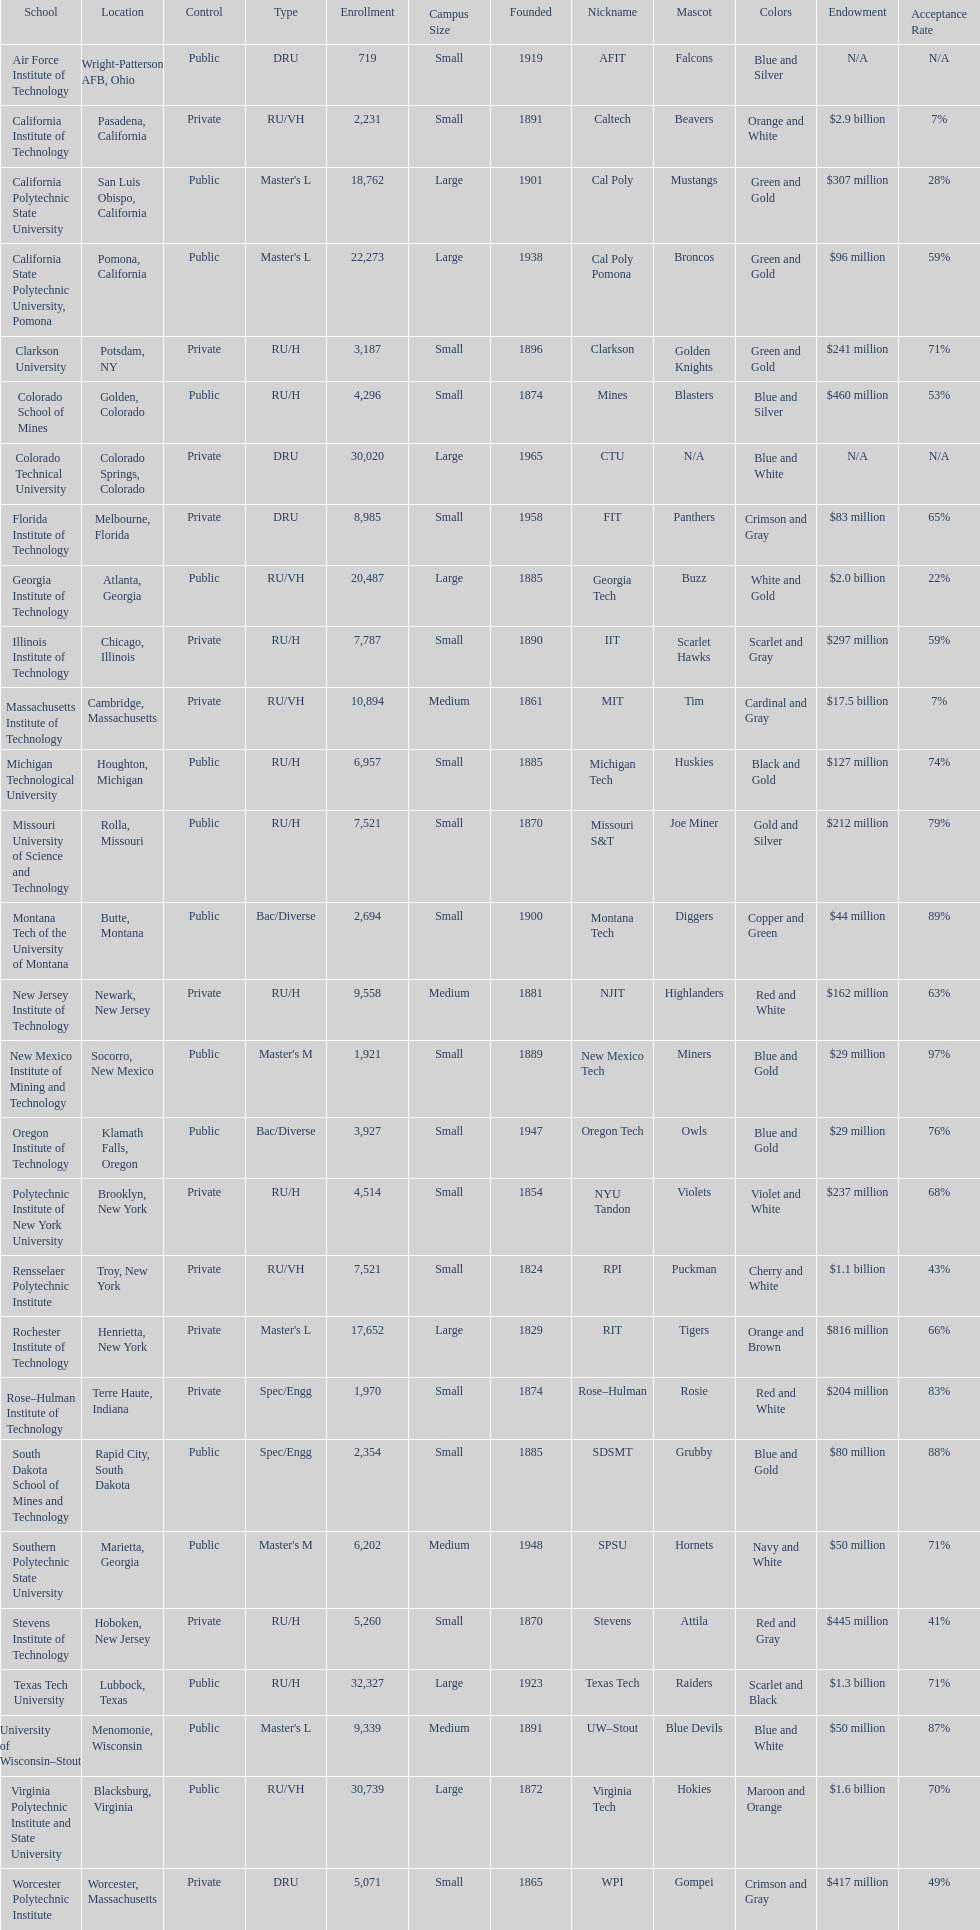In the table, what is the total number of schools displayed? 28. 